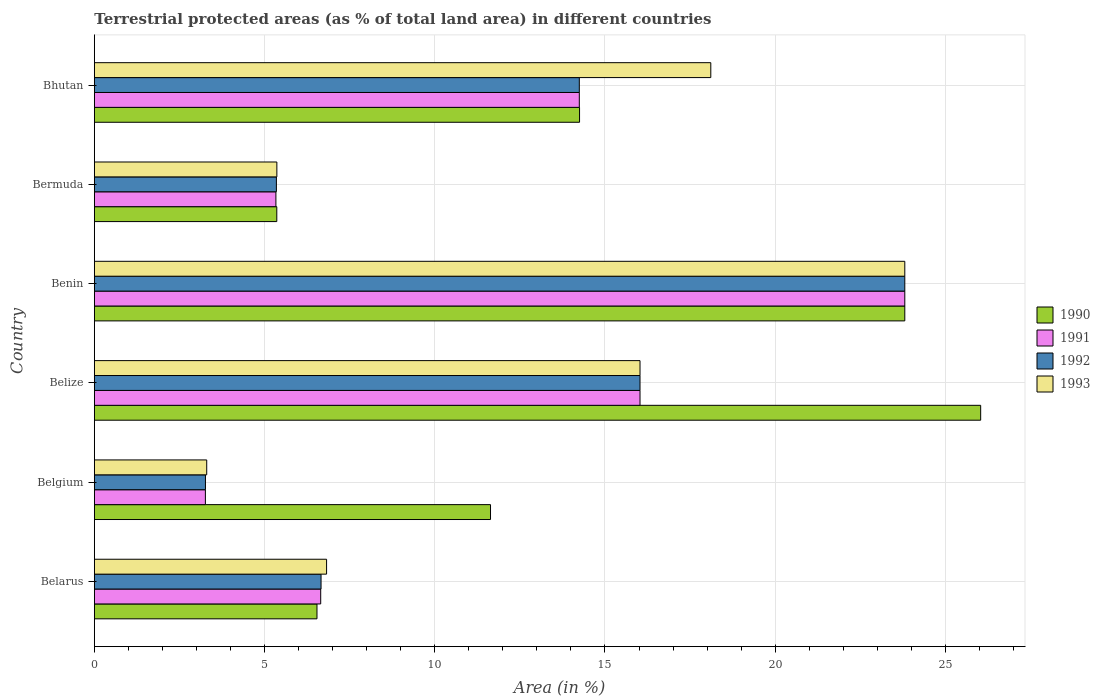How many different coloured bars are there?
Offer a very short reply. 4. How many groups of bars are there?
Your answer should be compact. 6. Are the number of bars per tick equal to the number of legend labels?
Your answer should be compact. Yes. Are the number of bars on each tick of the Y-axis equal?
Your response must be concise. Yes. How many bars are there on the 2nd tick from the top?
Your answer should be very brief. 4. How many bars are there on the 3rd tick from the bottom?
Offer a terse response. 4. What is the label of the 6th group of bars from the top?
Give a very brief answer. Belarus. What is the percentage of terrestrial protected land in 1993 in Bermuda?
Give a very brief answer. 5.36. Across all countries, what is the maximum percentage of terrestrial protected land in 1992?
Offer a very short reply. 23.81. Across all countries, what is the minimum percentage of terrestrial protected land in 1993?
Make the answer very short. 3.3. In which country was the percentage of terrestrial protected land in 1991 maximum?
Your answer should be very brief. Benin. In which country was the percentage of terrestrial protected land in 1990 minimum?
Ensure brevity in your answer.  Bermuda. What is the total percentage of terrestrial protected land in 1991 in the graph?
Offer a terse response. 69.33. What is the difference between the percentage of terrestrial protected land in 1992 in Belarus and that in Benin?
Your response must be concise. -17.15. What is the difference between the percentage of terrestrial protected land in 1990 in Belarus and the percentage of terrestrial protected land in 1993 in Belize?
Your answer should be very brief. -9.49. What is the average percentage of terrestrial protected land in 1990 per country?
Your answer should be compact. 14.61. What is the difference between the percentage of terrestrial protected land in 1990 and percentage of terrestrial protected land in 1992 in Belgium?
Your answer should be compact. 8.37. In how many countries, is the percentage of terrestrial protected land in 1992 greater than 16 %?
Provide a short and direct response. 2. What is the ratio of the percentage of terrestrial protected land in 1991 in Belgium to that in Bermuda?
Give a very brief answer. 0.61. Is the percentage of terrestrial protected land in 1992 in Belgium less than that in Bhutan?
Provide a succinct answer. Yes. What is the difference between the highest and the second highest percentage of terrestrial protected land in 1992?
Offer a very short reply. 7.78. What is the difference between the highest and the lowest percentage of terrestrial protected land in 1991?
Your answer should be compact. 20.54. Is the sum of the percentage of terrestrial protected land in 1991 in Belarus and Bermuda greater than the maximum percentage of terrestrial protected land in 1990 across all countries?
Make the answer very short. No. Is it the case that in every country, the sum of the percentage of terrestrial protected land in 1993 and percentage of terrestrial protected land in 1992 is greater than the sum of percentage of terrestrial protected land in 1990 and percentage of terrestrial protected land in 1991?
Make the answer very short. No. Is it the case that in every country, the sum of the percentage of terrestrial protected land in 1990 and percentage of terrestrial protected land in 1992 is greater than the percentage of terrestrial protected land in 1991?
Provide a succinct answer. Yes. How many bars are there?
Make the answer very short. 24. Are all the bars in the graph horizontal?
Give a very brief answer. Yes. How many countries are there in the graph?
Provide a succinct answer. 6. What is the difference between two consecutive major ticks on the X-axis?
Your answer should be very brief. 5. Are the values on the major ticks of X-axis written in scientific E-notation?
Your answer should be very brief. No. How many legend labels are there?
Provide a short and direct response. 4. What is the title of the graph?
Make the answer very short. Terrestrial protected areas (as % of total land area) in different countries. Does "1974" appear as one of the legend labels in the graph?
Your answer should be compact. No. What is the label or title of the X-axis?
Offer a very short reply. Area (in %). What is the Area (in %) in 1990 in Belarus?
Give a very brief answer. 6.54. What is the Area (in %) of 1991 in Belarus?
Your answer should be compact. 6.65. What is the Area (in %) of 1992 in Belarus?
Your response must be concise. 6.66. What is the Area (in %) in 1993 in Belarus?
Provide a short and direct response. 6.82. What is the Area (in %) of 1990 in Belgium?
Offer a very short reply. 11.64. What is the Area (in %) in 1991 in Belgium?
Ensure brevity in your answer.  3.26. What is the Area (in %) in 1992 in Belgium?
Your response must be concise. 3.26. What is the Area (in %) of 1993 in Belgium?
Your answer should be compact. 3.3. What is the Area (in %) in 1990 in Belize?
Provide a succinct answer. 26.04. What is the Area (in %) of 1991 in Belize?
Your answer should be compact. 16.03. What is the Area (in %) in 1992 in Belize?
Offer a terse response. 16.03. What is the Area (in %) in 1993 in Belize?
Provide a short and direct response. 16.03. What is the Area (in %) of 1990 in Benin?
Keep it short and to the point. 23.81. What is the Area (in %) of 1991 in Benin?
Provide a short and direct response. 23.81. What is the Area (in %) in 1992 in Benin?
Your response must be concise. 23.81. What is the Area (in %) in 1993 in Benin?
Give a very brief answer. 23.81. What is the Area (in %) in 1990 in Bermuda?
Give a very brief answer. 5.36. What is the Area (in %) of 1991 in Bermuda?
Offer a terse response. 5.33. What is the Area (in %) of 1992 in Bermuda?
Provide a short and direct response. 5.35. What is the Area (in %) of 1993 in Bermuda?
Make the answer very short. 5.36. What is the Area (in %) of 1990 in Bhutan?
Provide a succinct answer. 14.25. What is the Area (in %) in 1991 in Bhutan?
Make the answer very short. 14.25. What is the Area (in %) in 1992 in Bhutan?
Offer a terse response. 14.25. What is the Area (in %) of 1993 in Bhutan?
Your answer should be compact. 18.11. Across all countries, what is the maximum Area (in %) of 1990?
Offer a terse response. 26.04. Across all countries, what is the maximum Area (in %) in 1991?
Your answer should be compact. 23.81. Across all countries, what is the maximum Area (in %) of 1992?
Your response must be concise. 23.81. Across all countries, what is the maximum Area (in %) of 1993?
Make the answer very short. 23.81. Across all countries, what is the minimum Area (in %) of 1990?
Your answer should be compact. 5.36. Across all countries, what is the minimum Area (in %) in 1991?
Keep it short and to the point. 3.26. Across all countries, what is the minimum Area (in %) in 1992?
Make the answer very short. 3.26. Across all countries, what is the minimum Area (in %) of 1993?
Keep it short and to the point. 3.3. What is the total Area (in %) of 1990 in the graph?
Provide a succinct answer. 87.63. What is the total Area (in %) of 1991 in the graph?
Your answer should be very brief. 69.33. What is the total Area (in %) of 1992 in the graph?
Provide a succinct answer. 69.35. What is the total Area (in %) in 1993 in the graph?
Provide a succinct answer. 73.43. What is the difference between the Area (in %) in 1990 in Belarus and that in Belgium?
Your answer should be very brief. -5.1. What is the difference between the Area (in %) in 1991 in Belarus and that in Belgium?
Keep it short and to the point. 3.39. What is the difference between the Area (in %) of 1992 in Belarus and that in Belgium?
Keep it short and to the point. 3.4. What is the difference between the Area (in %) in 1993 in Belarus and that in Belgium?
Offer a very short reply. 3.52. What is the difference between the Area (in %) of 1990 in Belarus and that in Belize?
Your answer should be very brief. -19.5. What is the difference between the Area (in %) in 1991 in Belarus and that in Belize?
Provide a succinct answer. -9.38. What is the difference between the Area (in %) in 1992 in Belarus and that in Belize?
Give a very brief answer. -9.37. What is the difference between the Area (in %) in 1993 in Belarus and that in Belize?
Ensure brevity in your answer.  -9.21. What is the difference between the Area (in %) in 1990 in Belarus and that in Benin?
Your response must be concise. -17.27. What is the difference between the Area (in %) in 1991 in Belarus and that in Benin?
Provide a succinct answer. -17.16. What is the difference between the Area (in %) in 1992 in Belarus and that in Benin?
Ensure brevity in your answer.  -17.15. What is the difference between the Area (in %) of 1993 in Belarus and that in Benin?
Offer a very short reply. -16.99. What is the difference between the Area (in %) of 1990 in Belarus and that in Bermuda?
Give a very brief answer. 1.18. What is the difference between the Area (in %) in 1991 in Belarus and that in Bermuda?
Give a very brief answer. 1.32. What is the difference between the Area (in %) of 1992 in Belarus and that in Bermuda?
Your answer should be compact. 1.31. What is the difference between the Area (in %) in 1993 in Belarus and that in Bermuda?
Offer a terse response. 1.46. What is the difference between the Area (in %) of 1990 in Belarus and that in Bhutan?
Keep it short and to the point. -7.71. What is the difference between the Area (in %) in 1991 in Belarus and that in Bhutan?
Ensure brevity in your answer.  -7.6. What is the difference between the Area (in %) of 1992 in Belarus and that in Bhutan?
Give a very brief answer. -7.59. What is the difference between the Area (in %) in 1993 in Belarus and that in Bhutan?
Your response must be concise. -11.29. What is the difference between the Area (in %) of 1990 in Belgium and that in Belize?
Your answer should be compact. -14.4. What is the difference between the Area (in %) in 1991 in Belgium and that in Belize?
Ensure brevity in your answer.  -12.77. What is the difference between the Area (in %) in 1992 in Belgium and that in Belize?
Keep it short and to the point. -12.77. What is the difference between the Area (in %) in 1993 in Belgium and that in Belize?
Your response must be concise. -12.73. What is the difference between the Area (in %) of 1990 in Belgium and that in Benin?
Offer a terse response. -12.17. What is the difference between the Area (in %) in 1991 in Belgium and that in Benin?
Keep it short and to the point. -20.55. What is the difference between the Area (in %) of 1992 in Belgium and that in Benin?
Offer a terse response. -20.54. What is the difference between the Area (in %) in 1993 in Belgium and that in Benin?
Your response must be concise. -20.51. What is the difference between the Area (in %) in 1990 in Belgium and that in Bermuda?
Provide a succinct answer. 6.28. What is the difference between the Area (in %) in 1991 in Belgium and that in Bermuda?
Provide a succinct answer. -2.07. What is the difference between the Area (in %) in 1992 in Belgium and that in Bermuda?
Your answer should be very brief. -2.08. What is the difference between the Area (in %) of 1993 in Belgium and that in Bermuda?
Provide a succinct answer. -2.06. What is the difference between the Area (in %) in 1990 in Belgium and that in Bhutan?
Make the answer very short. -2.62. What is the difference between the Area (in %) of 1991 in Belgium and that in Bhutan?
Your answer should be very brief. -10.98. What is the difference between the Area (in %) in 1992 in Belgium and that in Bhutan?
Ensure brevity in your answer.  -10.98. What is the difference between the Area (in %) in 1993 in Belgium and that in Bhutan?
Ensure brevity in your answer.  -14.81. What is the difference between the Area (in %) of 1990 in Belize and that in Benin?
Make the answer very short. 2.23. What is the difference between the Area (in %) in 1991 in Belize and that in Benin?
Make the answer very short. -7.78. What is the difference between the Area (in %) in 1992 in Belize and that in Benin?
Offer a very short reply. -7.78. What is the difference between the Area (in %) of 1993 in Belize and that in Benin?
Your response must be concise. -7.78. What is the difference between the Area (in %) of 1990 in Belize and that in Bermuda?
Provide a short and direct response. 20.68. What is the difference between the Area (in %) in 1991 in Belize and that in Bermuda?
Provide a succinct answer. 10.7. What is the difference between the Area (in %) of 1992 in Belize and that in Bermuda?
Give a very brief answer. 10.68. What is the difference between the Area (in %) in 1993 in Belize and that in Bermuda?
Ensure brevity in your answer.  10.67. What is the difference between the Area (in %) in 1990 in Belize and that in Bhutan?
Keep it short and to the point. 11.78. What is the difference between the Area (in %) of 1991 in Belize and that in Bhutan?
Your response must be concise. 1.78. What is the difference between the Area (in %) of 1992 in Belize and that in Bhutan?
Give a very brief answer. 1.78. What is the difference between the Area (in %) in 1993 in Belize and that in Bhutan?
Make the answer very short. -2.08. What is the difference between the Area (in %) of 1990 in Benin and that in Bermuda?
Make the answer very short. 18.45. What is the difference between the Area (in %) of 1991 in Benin and that in Bermuda?
Give a very brief answer. 18.47. What is the difference between the Area (in %) of 1992 in Benin and that in Bermuda?
Your answer should be very brief. 18.46. What is the difference between the Area (in %) of 1993 in Benin and that in Bermuda?
Keep it short and to the point. 18.45. What is the difference between the Area (in %) of 1990 in Benin and that in Bhutan?
Your answer should be very brief. 9.55. What is the difference between the Area (in %) in 1991 in Benin and that in Bhutan?
Your answer should be very brief. 9.56. What is the difference between the Area (in %) of 1992 in Benin and that in Bhutan?
Your answer should be compact. 9.56. What is the difference between the Area (in %) in 1993 in Benin and that in Bhutan?
Provide a succinct answer. 5.7. What is the difference between the Area (in %) of 1990 in Bermuda and that in Bhutan?
Your answer should be compact. -8.89. What is the difference between the Area (in %) in 1991 in Bermuda and that in Bhutan?
Keep it short and to the point. -8.91. What is the difference between the Area (in %) in 1992 in Bermuda and that in Bhutan?
Offer a very short reply. -8.9. What is the difference between the Area (in %) in 1993 in Bermuda and that in Bhutan?
Your answer should be very brief. -12.75. What is the difference between the Area (in %) of 1990 in Belarus and the Area (in %) of 1991 in Belgium?
Provide a succinct answer. 3.28. What is the difference between the Area (in %) in 1990 in Belarus and the Area (in %) in 1992 in Belgium?
Your response must be concise. 3.28. What is the difference between the Area (in %) of 1990 in Belarus and the Area (in %) of 1993 in Belgium?
Provide a short and direct response. 3.24. What is the difference between the Area (in %) in 1991 in Belarus and the Area (in %) in 1992 in Belgium?
Your response must be concise. 3.39. What is the difference between the Area (in %) of 1991 in Belarus and the Area (in %) of 1993 in Belgium?
Offer a very short reply. 3.35. What is the difference between the Area (in %) of 1992 in Belarus and the Area (in %) of 1993 in Belgium?
Your answer should be compact. 3.36. What is the difference between the Area (in %) of 1990 in Belarus and the Area (in %) of 1991 in Belize?
Make the answer very short. -9.49. What is the difference between the Area (in %) of 1990 in Belarus and the Area (in %) of 1992 in Belize?
Keep it short and to the point. -9.49. What is the difference between the Area (in %) in 1990 in Belarus and the Area (in %) in 1993 in Belize?
Your answer should be compact. -9.49. What is the difference between the Area (in %) of 1991 in Belarus and the Area (in %) of 1992 in Belize?
Your answer should be very brief. -9.38. What is the difference between the Area (in %) in 1991 in Belarus and the Area (in %) in 1993 in Belize?
Offer a terse response. -9.38. What is the difference between the Area (in %) in 1992 in Belarus and the Area (in %) in 1993 in Belize?
Your answer should be very brief. -9.37. What is the difference between the Area (in %) in 1990 in Belarus and the Area (in %) in 1991 in Benin?
Provide a succinct answer. -17.27. What is the difference between the Area (in %) of 1990 in Belarus and the Area (in %) of 1992 in Benin?
Provide a succinct answer. -17.27. What is the difference between the Area (in %) in 1990 in Belarus and the Area (in %) in 1993 in Benin?
Your answer should be compact. -17.27. What is the difference between the Area (in %) in 1991 in Belarus and the Area (in %) in 1992 in Benin?
Provide a short and direct response. -17.16. What is the difference between the Area (in %) in 1991 in Belarus and the Area (in %) in 1993 in Benin?
Make the answer very short. -17.16. What is the difference between the Area (in %) in 1992 in Belarus and the Area (in %) in 1993 in Benin?
Offer a very short reply. -17.15. What is the difference between the Area (in %) in 1990 in Belarus and the Area (in %) in 1991 in Bermuda?
Your answer should be compact. 1.21. What is the difference between the Area (in %) in 1990 in Belarus and the Area (in %) in 1992 in Bermuda?
Offer a terse response. 1.19. What is the difference between the Area (in %) in 1990 in Belarus and the Area (in %) in 1993 in Bermuda?
Your answer should be compact. 1.18. What is the difference between the Area (in %) in 1991 in Belarus and the Area (in %) in 1992 in Bermuda?
Provide a short and direct response. 1.3. What is the difference between the Area (in %) of 1991 in Belarus and the Area (in %) of 1993 in Bermuda?
Your answer should be very brief. 1.29. What is the difference between the Area (in %) in 1992 in Belarus and the Area (in %) in 1993 in Bermuda?
Your answer should be compact. 1.3. What is the difference between the Area (in %) of 1990 in Belarus and the Area (in %) of 1991 in Bhutan?
Your response must be concise. -7.71. What is the difference between the Area (in %) in 1990 in Belarus and the Area (in %) in 1992 in Bhutan?
Provide a short and direct response. -7.71. What is the difference between the Area (in %) of 1990 in Belarus and the Area (in %) of 1993 in Bhutan?
Ensure brevity in your answer.  -11.57. What is the difference between the Area (in %) in 1991 in Belarus and the Area (in %) in 1992 in Bhutan?
Keep it short and to the point. -7.6. What is the difference between the Area (in %) in 1991 in Belarus and the Area (in %) in 1993 in Bhutan?
Offer a terse response. -11.46. What is the difference between the Area (in %) in 1992 in Belarus and the Area (in %) in 1993 in Bhutan?
Provide a short and direct response. -11.45. What is the difference between the Area (in %) in 1990 in Belgium and the Area (in %) in 1991 in Belize?
Provide a succinct answer. -4.39. What is the difference between the Area (in %) of 1990 in Belgium and the Area (in %) of 1992 in Belize?
Make the answer very short. -4.39. What is the difference between the Area (in %) in 1990 in Belgium and the Area (in %) in 1993 in Belize?
Offer a terse response. -4.39. What is the difference between the Area (in %) in 1991 in Belgium and the Area (in %) in 1992 in Belize?
Provide a short and direct response. -12.77. What is the difference between the Area (in %) of 1991 in Belgium and the Area (in %) of 1993 in Belize?
Provide a short and direct response. -12.77. What is the difference between the Area (in %) of 1992 in Belgium and the Area (in %) of 1993 in Belize?
Your response must be concise. -12.77. What is the difference between the Area (in %) in 1990 in Belgium and the Area (in %) in 1991 in Benin?
Your answer should be compact. -12.17. What is the difference between the Area (in %) in 1990 in Belgium and the Area (in %) in 1992 in Benin?
Offer a very short reply. -12.17. What is the difference between the Area (in %) of 1990 in Belgium and the Area (in %) of 1993 in Benin?
Keep it short and to the point. -12.17. What is the difference between the Area (in %) of 1991 in Belgium and the Area (in %) of 1992 in Benin?
Offer a very short reply. -20.55. What is the difference between the Area (in %) of 1991 in Belgium and the Area (in %) of 1993 in Benin?
Your answer should be compact. -20.55. What is the difference between the Area (in %) of 1992 in Belgium and the Area (in %) of 1993 in Benin?
Your answer should be very brief. -20.54. What is the difference between the Area (in %) of 1990 in Belgium and the Area (in %) of 1991 in Bermuda?
Your answer should be compact. 6.3. What is the difference between the Area (in %) in 1990 in Belgium and the Area (in %) in 1992 in Bermuda?
Your response must be concise. 6.29. What is the difference between the Area (in %) in 1990 in Belgium and the Area (in %) in 1993 in Bermuda?
Offer a terse response. 6.28. What is the difference between the Area (in %) of 1991 in Belgium and the Area (in %) of 1992 in Bermuda?
Your answer should be compact. -2.09. What is the difference between the Area (in %) in 1991 in Belgium and the Area (in %) in 1993 in Bermuda?
Your answer should be very brief. -2.1. What is the difference between the Area (in %) of 1992 in Belgium and the Area (in %) of 1993 in Bermuda?
Offer a terse response. -2.1. What is the difference between the Area (in %) of 1990 in Belgium and the Area (in %) of 1991 in Bhutan?
Give a very brief answer. -2.61. What is the difference between the Area (in %) of 1990 in Belgium and the Area (in %) of 1992 in Bhutan?
Your response must be concise. -2.61. What is the difference between the Area (in %) of 1990 in Belgium and the Area (in %) of 1993 in Bhutan?
Give a very brief answer. -6.47. What is the difference between the Area (in %) in 1991 in Belgium and the Area (in %) in 1992 in Bhutan?
Keep it short and to the point. -10.98. What is the difference between the Area (in %) in 1991 in Belgium and the Area (in %) in 1993 in Bhutan?
Give a very brief answer. -14.85. What is the difference between the Area (in %) of 1992 in Belgium and the Area (in %) of 1993 in Bhutan?
Make the answer very short. -14.84. What is the difference between the Area (in %) of 1990 in Belize and the Area (in %) of 1991 in Benin?
Provide a short and direct response. 2.23. What is the difference between the Area (in %) in 1990 in Belize and the Area (in %) in 1992 in Benin?
Offer a very short reply. 2.23. What is the difference between the Area (in %) in 1990 in Belize and the Area (in %) in 1993 in Benin?
Offer a terse response. 2.23. What is the difference between the Area (in %) in 1991 in Belize and the Area (in %) in 1992 in Benin?
Your answer should be compact. -7.78. What is the difference between the Area (in %) of 1991 in Belize and the Area (in %) of 1993 in Benin?
Your response must be concise. -7.78. What is the difference between the Area (in %) of 1992 in Belize and the Area (in %) of 1993 in Benin?
Offer a terse response. -7.78. What is the difference between the Area (in %) of 1990 in Belize and the Area (in %) of 1991 in Bermuda?
Your response must be concise. 20.7. What is the difference between the Area (in %) of 1990 in Belize and the Area (in %) of 1992 in Bermuda?
Make the answer very short. 20.69. What is the difference between the Area (in %) of 1990 in Belize and the Area (in %) of 1993 in Bermuda?
Your response must be concise. 20.67. What is the difference between the Area (in %) in 1991 in Belize and the Area (in %) in 1992 in Bermuda?
Give a very brief answer. 10.68. What is the difference between the Area (in %) of 1991 in Belize and the Area (in %) of 1993 in Bermuda?
Your answer should be very brief. 10.67. What is the difference between the Area (in %) in 1992 in Belize and the Area (in %) in 1993 in Bermuda?
Offer a terse response. 10.67. What is the difference between the Area (in %) in 1990 in Belize and the Area (in %) in 1991 in Bhutan?
Give a very brief answer. 11.79. What is the difference between the Area (in %) of 1990 in Belize and the Area (in %) of 1992 in Bhutan?
Make the answer very short. 11.79. What is the difference between the Area (in %) of 1990 in Belize and the Area (in %) of 1993 in Bhutan?
Provide a succinct answer. 7.93. What is the difference between the Area (in %) in 1991 in Belize and the Area (in %) in 1992 in Bhutan?
Keep it short and to the point. 1.78. What is the difference between the Area (in %) of 1991 in Belize and the Area (in %) of 1993 in Bhutan?
Offer a terse response. -2.08. What is the difference between the Area (in %) in 1992 in Belize and the Area (in %) in 1993 in Bhutan?
Give a very brief answer. -2.08. What is the difference between the Area (in %) of 1990 in Benin and the Area (in %) of 1991 in Bermuda?
Your response must be concise. 18.47. What is the difference between the Area (in %) in 1990 in Benin and the Area (in %) in 1992 in Bermuda?
Your response must be concise. 18.46. What is the difference between the Area (in %) of 1990 in Benin and the Area (in %) of 1993 in Bermuda?
Your response must be concise. 18.45. What is the difference between the Area (in %) in 1991 in Benin and the Area (in %) in 1992 in Bermuda?
Your answer should be compact. 18.46. What is the difference between the Area (in %) of 1991 in Benin and the Area (in %) of 1993 in Bermuda?
Ensure brevity in your answer.  18.45. What is the difference between the Area (in %) of 1992 in Benin and the Area (in %) of 1993 in Bermuda?
Provide a short and direct response. 18.45. What is the difference between the Area (in %) of 1990 in Benin and the Area (in %) of 1991 in Bhutan?
Offer a terse response. 9.56. What is the difference between the Area (in %) in 1990 in Benin and the Area (in %) in 1992 in Bhutan?
Offer a terse response. 9.56. What is the difference between the Area (in %) of 1990 in Benin and the Area (in %) of 1993 in Bhutan?
Your answer should be compact. 5.7. What is the difference between the Area (in %) in 1991 in Benin and the Area (in %) in 1992 in Bhutan?
Make the answer very short. 9.56. What is the difference between the Area (in %) in 1991 in Benin and the Area (in %) in 1993 in Bhutan?
Make the answer very short. 5.7. What is the difference between the Area (in %) in 1992 in Benin and the Area (in %) in 1993 in Bhutan?
Your answer should be very brief. 5.7. What is the difference between the Area (in %) in 1990 in Bermuda and the Area (in %) in 1991 in Bhutan?
Your answer should be very brief. -8.89. What is the difference between the Area (in %) in 1990 in Bermuda and the Area (in %) in 1992 in Bhutan?
Your response must be concise. -8.89. What is the difference between the Area (in %) in 1990 in Bermuda and the Area (in %) in 1993 in Bhutan?
Your response must be concise. -12.75. What is the difference between the Area (in %) in 1991 in Bermuda and the Area (in %) in 1992 in Bhutan?
Provide a succinct answer. -8.91. What is the difference between the Area (in %) in 1991 in Bermuda and the Area (in %) in 1993 in Bhutan?
Give a very brief answer. -12.77. What is the difference between the Area (in %) in 1992 in Bermuda and the Area (in %) in 1993 in Bhutan?
Offer a terse response. -12.76. What is the average Area (in %) in 1990 per country?
Your response must be concise. 14.61. What is the average Area (in %) of 1991 per country?
Give a very brief answer. 11.55. What is the average Area (in %) of 1992 per country?
Give a very brief answer. 11.56. What is the average Area (in %) in 1993 per country?
Keep it short and to the point. 12.24. What is the difference between the Area (in %) in 1990 and Area (in %) in 1991 in Belarus?
Your answer should be very brief. -0.11. What is the difference between the Area (in %) in 1990 and Area (in %) in 1992 in Belarus?
Your answer should be compact. -0.12. What is the difference between the Area (in %) in 1990 and Area (in %) in 1993 in Belarus?
Keep it short and to the point. -0.28. What is the difference between the Area (in %) of 1991 and Area (in %) of 1992 in Belarus?
Offer a very short reply. -0.01. What is the difference between the Area (in %) in 1991 and Area (in %) in 1993 in Belarus?
Your answer should be compact. -0.17. What is the difference between the Area (in %) of 1992 and Area (in %) of 1993 in Belarus?
Your answer should be compact. -0.16. What is the difference between the Area (in %) in 1990 and Area (in %) in 1991 in Belgium?
Offer a terse response. 8.38. What is the difference between the Area (in %) of 1990 and Area (in %) of 1992 in Belgium?
Ensure brevity in your answer.  8.37. What is the difference between the Area (in %) in 1990 and Area (in %) in 1993 in Belgium?
Your response must be concise. 8.34. What is the difference between the Area (in %) of 1991 and Area (in %) of 1992 in Belgium?
Your response must be concise. -0. What is the difference between the Area (in %) in 1991 and Area (in %) in 1993 in Belgium?
Provide a short and direct response. -0.04. What is the difference between the Area (in %) of 1992 and Area (in %) of 1993 in Belgium?
Provide a short and direct response. -0.04. What is the difference between the Area (in %) of 1990 and Area (in %) of 1991 in Belize?
Your answer should be compact. 10.01. What is the difference between the Area (in %) in 1990 and Area (in %) in 1992 in Belize?
Offer a terse response. 10.01. What is the difference between the Area (in %) in 1990 and Area (in %) in 1993 in Belize?
Provide a succinct answer. 10.01. What is the difference between the Area (in %) of 1990 and Area (in %) of 1993 in Benin?
Your answer should be very brief. 0. What is the difference between the Area (in %) of 1991 and Area (in %) of 1992 in Benin?
Make the answer very short. 0. What is the difference between the Area (in %) of 1990 and Area (in %) of 1991 in Bermuda?
Your answer should be very brief. 0.03. What is the difference between the Area (in %) in 1990 and Area (in %) in 1992 in Bermuda?
Ensure brevity in your answer.  0.01. What is the difference between the Area (in %) of 1990 and Area (in %) of 1993 in Bermuda?
Give a very brief answer. -0. What is the difference between the Area (in %) of 1991 and Area (in %) of 1992 in Bermuda?
Your response must be concise. -0.01. What is the difference between the Area (in %) in 1991 and Area (in %) in 1993 in Bermuda?
Offer a very short reply. -0.03. What is the difference between the Area (in %) in 1992 and Area (in %) in 1993 in Bermuda?
Ensure brevity in your answer.  -0.01. What is the difference between the Area (in %) in 1990 and Area (in %) in 1991 in Bhutan?
Your response must be concise. 0.01. What is the difference between the Area (in %) in 1990 and Area (in %) in 1992 in Bhutan?
Make the answer very short. 0.01. What is the difference between the Area (in %) in 1990 and Area (in %) in 1993 in Bhutan?
Provide a short and direct response. -3.86. What is the difference between the Area (in %) of 1991 and Area (in %) of 1993 in Bhutan?
Keep it short and to the point. -3.86. What is the difference between the Area (in %) of 1992 and Area (in %) of 1993 in Bhutan?
Offer a very short reply. -3.86. What is the ratio of the Area (in %) in 1990 in Belarus to that in Belgium?
Offer a terse response. 0.56. What is the ratio of the Area (in %) of 1991 in Belarus to that in Belgium?
Offer a terse response. 2.04. What is the ratio of the Area (in %) of 1992 in Belarus to that in Belgium?
Provide a short and direct response. 2.04. What is the ratio of the Area (in %) of 1993 in Belarus to that in Belgium?
Give a very brief answer. 2.07. What is the ratio of the Area (in %) in 1990 in Belarus to that in Belize?
Give a very brief answer. 0.25. What is the ratio of the Area (in %) in 1991 in Belarus to that in Belize?
Your answer should be compact. 0.41. What is the ratio of the Area (in %) of 1992 in Belarus to that in Belize?
Your response must be concise. 0.42. What is the ratio of the Area (in %) in 1993 in Belarus to that in Belize?
Offer a very short reply. 0.43. What is the ratio of the Area (in %) of 1990 in Belarus to that in Benin?
Give a very brief answer. 0.27. What is the ratio of the Area (in %) in 1991 in Belarus to that in Benin?
Your response must be concise. 0.28. What is the ratio of the Area (in %) in 1992 in Belarus to that in Benin?
Provide a succinct answer. 0.28. What is the ratio of the Area (in %) in 1993 in Belarus to that in Benin?
Offer a very short reply. 0.29. What is the ratio of the Area (in %) of 1990 in Belarus to that in Bermuda?
Your response must be concise. 1.22. What is the ratio of the Area (in %) in 1991 in Belarus to that in Bermuda?
Give a very brief answer. 1.25. What is the ratio of the Area (in %) of 1992 in Belarus to that in Bermuda?
Offer a very short reply. 1.25. What is the ratio of the Area (in %) of 1993 in Belarus to that in Bermuda?
Give a very brief answer. 1.27. What is the ratio of the Area (in %) in 1990 in Belarus to that in Bhutan?
Ensure brevity in your answer.  0.46. What is the ratio of the Area (in %) in 1991 in Belarus to that in Bhutan?
Give a very brief answer. 0.47. What is the ratio of the Area (in %) in 1992 in Belarus to that in Bhutan?
Your answer should be compact. 0.47. What is the ratio of the Area (in %) in 1993 in Belarus to that in Bhutan?
Make the answer very short. 0.38. What is the ratio of the Area (in %) in 1990 in Belgium to that in Belize?
Your answer should be compact. 0.45. What is the ratio of the Area (in %) of 1991 in Belgium to that in Belize?
Provide a short and direct response. 0.2. What is the ratio of the Area (in %) of 1992 in Belgium to that in Belize?
Provide a short and direct response. 0.2. What is the ratio of the Area (in %) in 1993 in Belgium to that in Belize?
Offer a very short reply. 0.21. What is the ratio of the Area (in %) of 1990 in Belgium to that in Benin?
Your response must be concise. 0.49. What is the ratio of the Area (in %) in 1991 in Belgium to that in Benin?
Ensure brevity in your answer.  0.14. What is the ratio of the Area (in %) in 1992 in Belgium to that in Benin?
Provide a short and direct response. 0.14. What is the ratio of the Area (in %) of 1993 in Belgium to that in Benin?
Your answer should be compact. 0.14. What is the ratio of the Area (in %) in 1990 in Belgium to that in Bermuda?
Give a very brief answer. 2.17. What is the ratio of the Area (in %) of 1991 in Belgium to that in Bermuda?
Provide a succinct answer. 0.61. What is the ratio of the Area (in %) of 1992 in Belgium to that in Bermuda?
Your answer should be very brief. 0.61. What is the ratio of the Area (in %) in 1993 in Belgium to that in Bermuda?
Your answer should be compact. 0.62. What is the ratio of the Area (in %) in 1990 in Belgium to that in Bhutan?
Make the answer very short. 0.82. What is the ratio of the Area (in %) in 1991 in Belgium to that in Bhutan?
Your answer should be very brief. 0.23. What is the ratio of the Area (in %) in 1992 in Belgium to that in Bhutan?
Make the answer very short. 0.23. What is the ratio of the Area (in %) of 1993 in Belgium to that in Bhutan?
Offer a terse response. 0.18. What is the ratio of the Area (in %) in 1990 in Belize to that in Benin?
Provide a succinct answer. 1.09. What is the ratio of the Area (in %) of 1991 in Belize to that in Benin?
Provide a short and direct response. 0.67. What is the ratio of the Area (in %) in 1992 in Belize to that in Benin?
Give a very brief answer. 0.67. What is the ratio of the Area (in %) in 1993 in Belize to that in Benin?
Provide a short and direct response. 0.67. What is the ratio of the Area (in %) in 1990 in Belize to that in Bermuda?
Make the answer very short. 4.86. What is the ratio of the Area (in %) of 1991 in Belize to that in Bermuda?
Offer a terse response. 3.01. What is the ratio of the Area (in %) of 1992 in Belize to that in Bermuda?
Your answer should be very brief. 3. What is the ratio of the Area (in %) of 1993 in Belize to that in Bermuda?
Your answer should be compact. 2.99. What is the ratio of the Area (in %) in 1990 in Belize to that in Bhutan?
Your answer should be very brief. 1.83. What is the ratio of the Area (in %) of 1991 in Belize to that in Bhutan?
Offer a terse response. 1.13. What is the ratio of the Area (in %) in 1992 in Belize to that in Bhutan?
Give a very brief answer. 1.13. What is the ratio of the Area (in %) in 1993 in Belize to that in Bhutan?
Your answer should be compact. 0.89. What is the ratio of the Area (in %) of 1990 in Benin to that in Bermuda?
Make the answer very short. 4.44. What is the ratio of the Area (in %) of 1991 in Benin to that in Bermuda?
Your answer should be compact. 4.46. What is the ratio of the Area (in %) in 1992 in Benin to that in Bermuda?
Ensure brevity in your answer.  4.45. What is the ratio of the Area (in %) of 1993 in Benin to that in Bermuda?
Your answer should be very brief. 4.44. What is the ratio of the Area (in %) of 1990 in Benin to that in Bhutan?
Provide a short and direct response. 1.67. What is the ratio of the Area (in %) in 1991 in Benin to that in Bhutan?
Make the answer very short. 1.67. What is the ratio of the Area (in %) of 1992 in Benin to that in Bhutan?
Make the answer very short. 1.67. What is the ratio of the Area (in %) in 1993 in Benin to that in Bhutan?
Ensure brevity in your answer.  1.31. What is the ratio of the Area (in %) in 1990 in Bermuda to that in Bhutan?
Offer a very short reply. 0.38. What is the ratio of the Area (in %) of 1991 in Bermuda to that in Bhutan?
Offer a very short reply. 0.37. What is the ratio of the Area (in %) of 1992 in Bermuda to that in Bhutan?
Make the answer very short. 0.38. What is the ratio of the Area (in %) of 1993 in Bermuda to that in Bhutan?
Keep it short and to the point. 0.3. What is the difference between the highest and the second highest Area (in %) in 1990?
Your response must be concise. 2.23. What is the difference between the highest and the second highest Area (in %) of 1991?
Ensure brevity in your answer.  7.78. What is the difference between the highest and the second highest Area (in %) of 1992?
Provide a short and direct response. 7.78. What is the difference between the highest and the second highest Area (in %) in 1993?
Provide a succinct answer. 5.7. What is the difference between the highest and the lowest Area (in %) of 1990?
Provide a short and direct response. 20.68. What is the difference between the highest and the lowest Area (in %) in 1991?
Provide a succinct answer. 20.55. What is the difference between the highest and the lowest Area (in %) in 1992?
Give a very brief answer. 20.54. What is the difference between the highest and the lowest Area (in %) of 1993?
Keep it short and to the point. 20.51. 